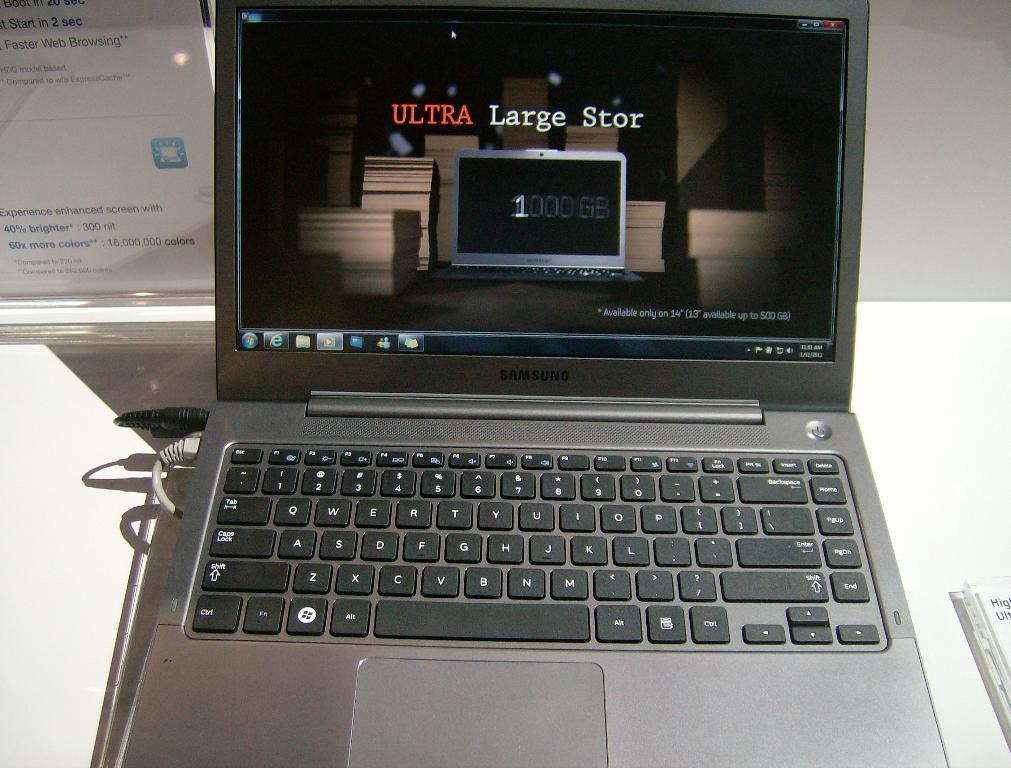<image>
Render a clear and concise summary of the photo. A laptop with Ultra Large Stor on the screen. 